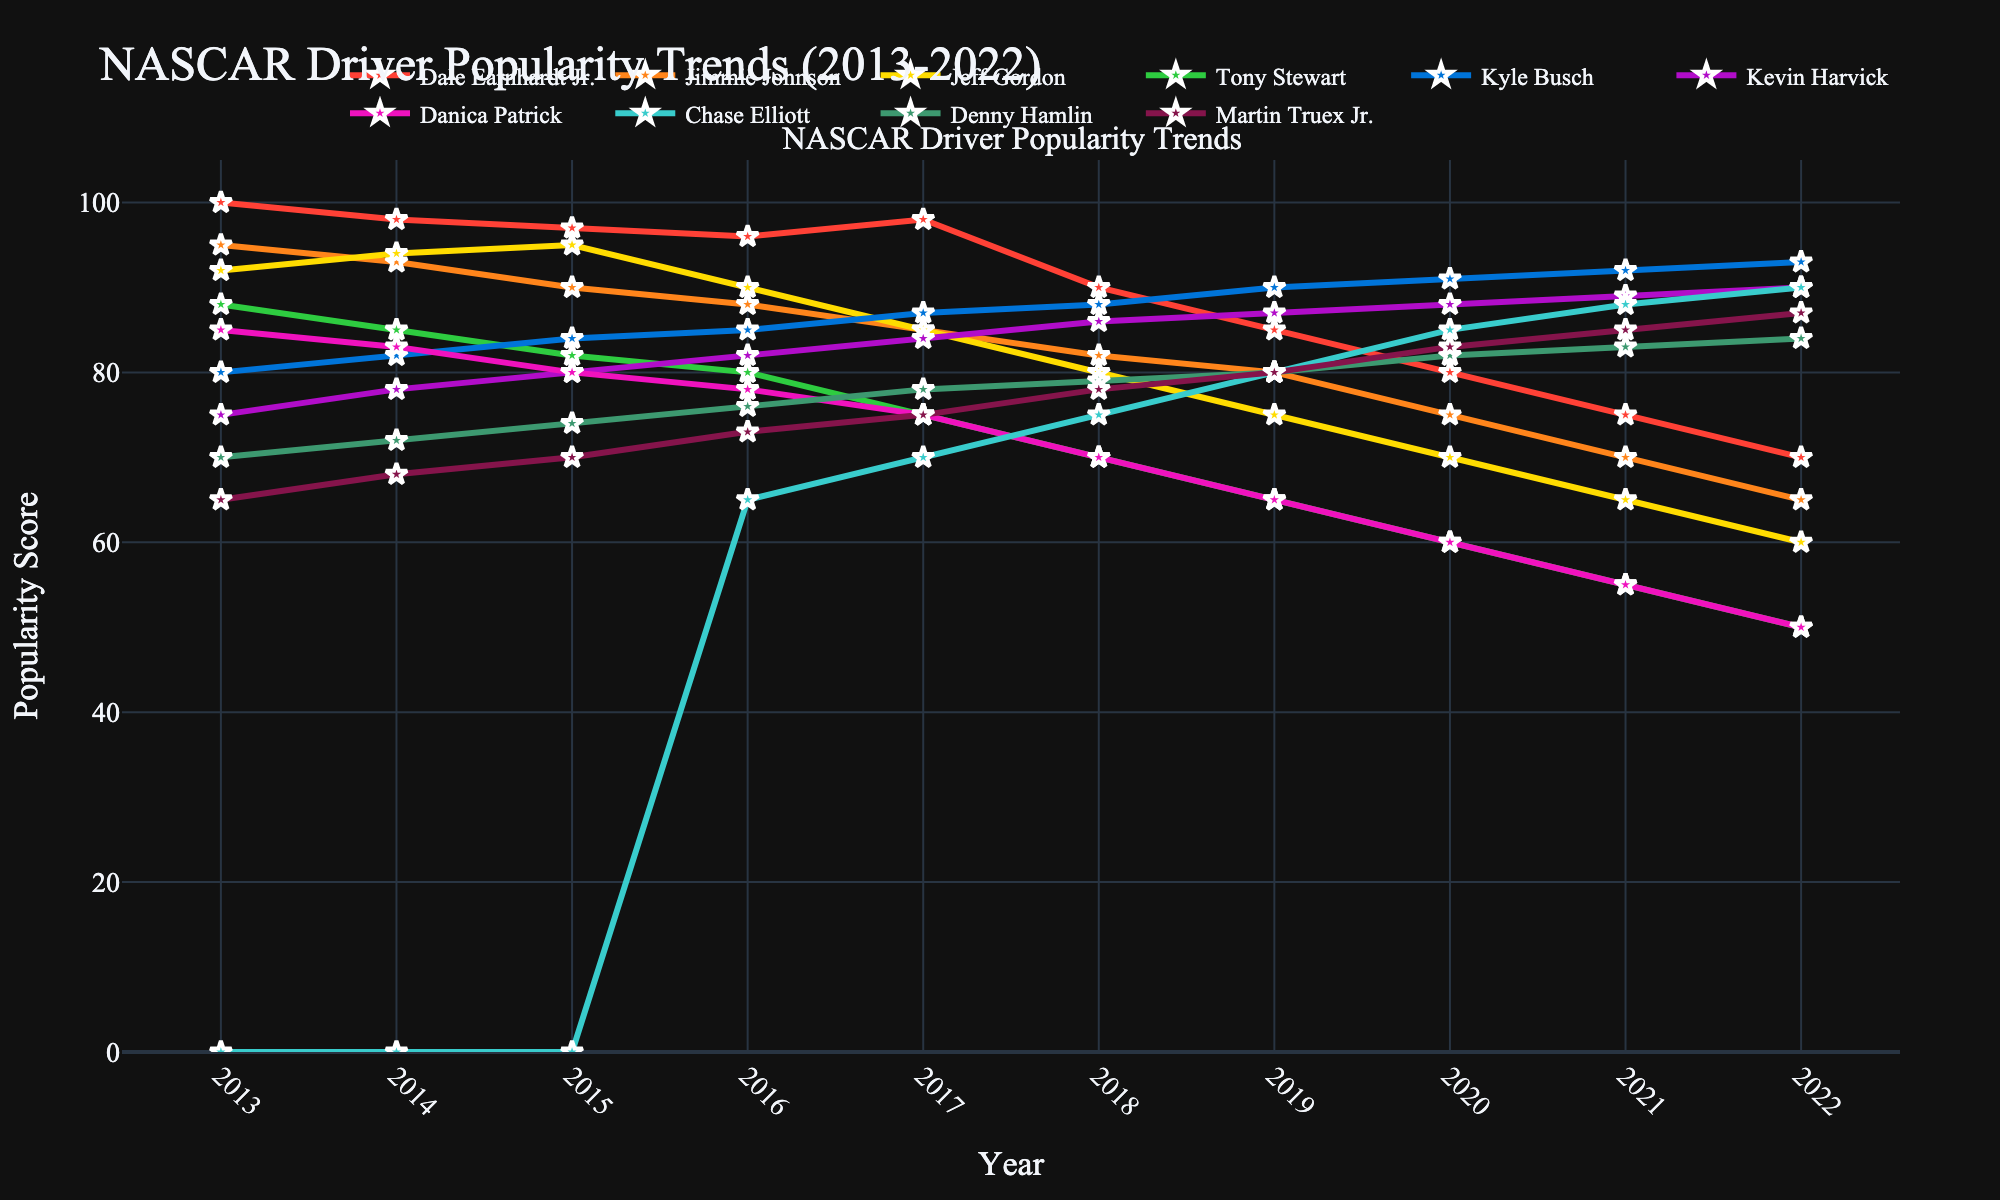Which driver had the highest popularity score in 2022? By observing the graph for 2022, we can see that Kyle Busch has the highest trend line at that year.
Answer: Kyle Busch In what year did Dale Earnhardt Jr. and Jimmie Johnson have the same popularity score? Observing the intersection points for Dale Earnhardt Jr. and Jimmie Johnson's lines, they align at the 2017 mark.
Answer: 2017 Which driver showed a consistent increase in popularity from 2013 to 2022? By examining the trends of all drivers, we notice Kyle Busch's line consistently moves upward across the years.
Answer: Kyle Busch What is the difference in popularity score between Chase Elliott and Danica Patrick in 2016? In 2016, Chase Elliott had a score of 65 and Danica Patrick had a score of 78. The difference is found by subtracting 65 from 78.
Answer: 13 Between 2013 and 2022, which driver experienced the greatest decline in popularity score? Examining the slopes from start to end, Dale Earnhardt Jr.'s score shows the largest drop from 100 to 70, totaling a decline of 30 points.
Answer: Dale Earnhardt Jr How many drivers had their highest popularity scores in 2017? By checking each line for their peak value, four drivers (Dale Earnhardt Jr., Jimmie Johnson, Kyle Busch, and Kevin Harvick) hit or share their highest scores in 2017.
Answer: Four drivers Which driver’s popularity declined the most between 2015 and 2018? Observing changes, Tony Stewart's score dropped from 82 in 2015 to 70 in 2018, making a decline of 12 points.
Answer: Tony Stewart What was the average popularity score for Jeff Gordon from 2013 to 2022? Summing Jeff Gordon's scores (92+94+95+90+85+80+75+70+65+60) equals 806. Dividing by 10 gives the average.
Answer: 80.6 In which year did Martin Truex Jr. surpass Denny Hamlin in popularity? By noting the years when Martin Truex Jr.’s score exceeds Denny Hamlin’s, it first occurs in 2018.
Answer: 2018 Who had the highest popularity score among the rookie drivers introduced in the data? Chase Elliott, starting from 0 in 2016, reached the highest score of 90 amongst new entries.
Answer: Chase Elliott 